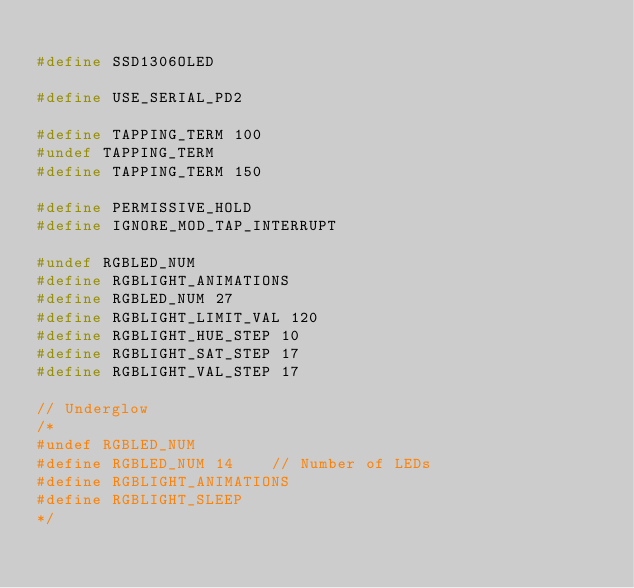Convert code to text. <code><loc_0><loc_0><loc_500><loc_500><_C_>
#define SSD1306OLED

#define USE_SERIAL_PD2

#define TAPPING_TERM 100
#undef TAPPING_TERM
#define TAPPING_TERM 150

#define PERMISSIVE_HOLD
#define IGNORE_MOD_TAP_INTERRUPT

#undef RGBLED_NUM
#define RGBLIGHT_ANIMATIONS
#define RGBLED_NUM 27
#define RGBLIGHT_LIMIT_VAL 120
#define RGBLIGHT_HUE_STEP 10
#define RGBLIGHT_SAT_STEP 17
#define RGBLIGHT_VAL_STEP 17

// Underglow
/*
#undef RGBLED_NUM
#define RGBLED_NUM 14    // Number of LEDs
#define RGBLIGHT_ANIMATIONS
#define RGBLIGHT_SLEEP
*/</code> 